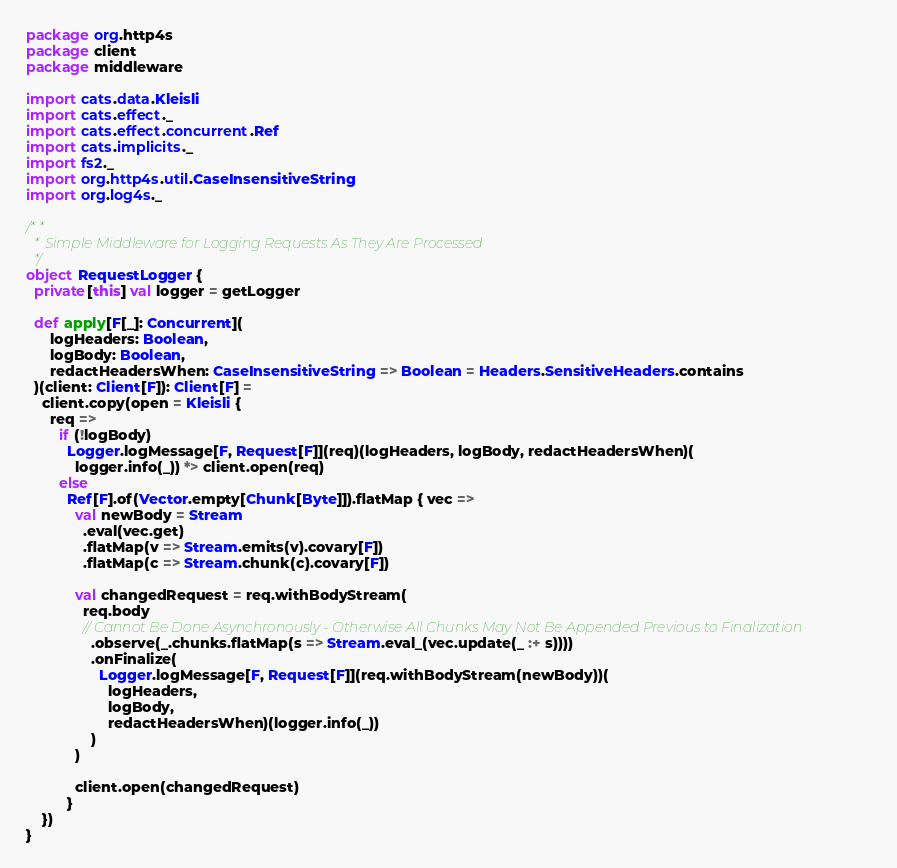Convert code to text. <code><loc_0><loc_0><loc_500><loc_500><_Scala_>package org.http4s
package client
package middleware

import cats.data.Kleisli
import cats.effect._
import cats.effect.concurrent.Ref
import cats.implicits._
import fs2._
import org.http4s.util.CaseInsensitiveString
import org.log4s._

/**
  * Simple Middleware for Logging Requests As They Are Processed
  */
object RequestLogger {
  private[this] val logger = getLogger

  def apply[F[_]: Concurrent](
      logHeaders: Boolean,
      logBody: Boolean,
      redactHeadersWhen: CaseInsensitiveString => Boolean = Headers.SensitiveHeaders.contains
  )(client: Client[F]): Client[F] =
    client.copy(open = Kleisli {
      req =>
        if (!logBody)
          Logger.logMessage[F, Request[F]](req)(logHeaders, logBody, redactHeadersWhen)(
            logger.info(_)) *> client.open(req)
        else
          Ref[F].of(Vector.empty[Chunk[Byte]]).flatMap { vec =>
            val newBody = Stream
              .eval(vec.get)
              .flatMap(v => Stream.emits(v).covary[F])
              .flatMap(c => Stream.chunk(c).covary[F])

            val changedRequest = req.withBodyStream(
              req.body
              // Cannot Be Done Asynchronously - Otherwise All Chunks May Not Be Appended Previous to Finalization
                .observe(_.chunks.flatMap(s => Stream.eval_(vec.update(_ :+ s))))
                .onFinalize(
                  Logger.logMessage[F, Request[F]](req.withBodyStream(newBody))(
                    logHeaders,
                    logBody,
                    redactHeadersWhen)(logger.info(_))
                )
            )

            client.open(changedRequest)
          }
    })
}
</code> 